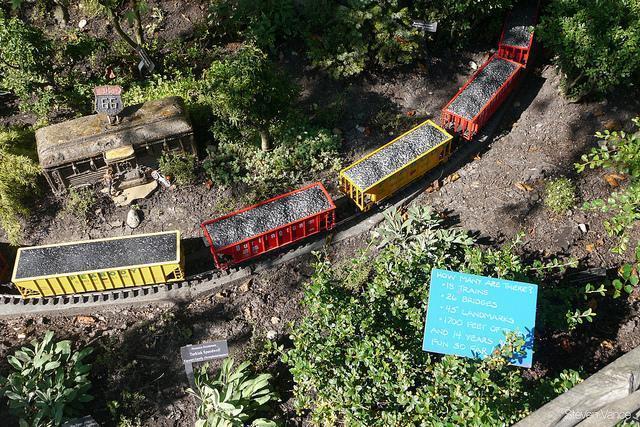How many humans could ride on this train?
Give a very brief answer. 0. How many train cars are there?
Give a very brief answer. 5. How many laptops are on the table?
Give a very brief answer. 0. 